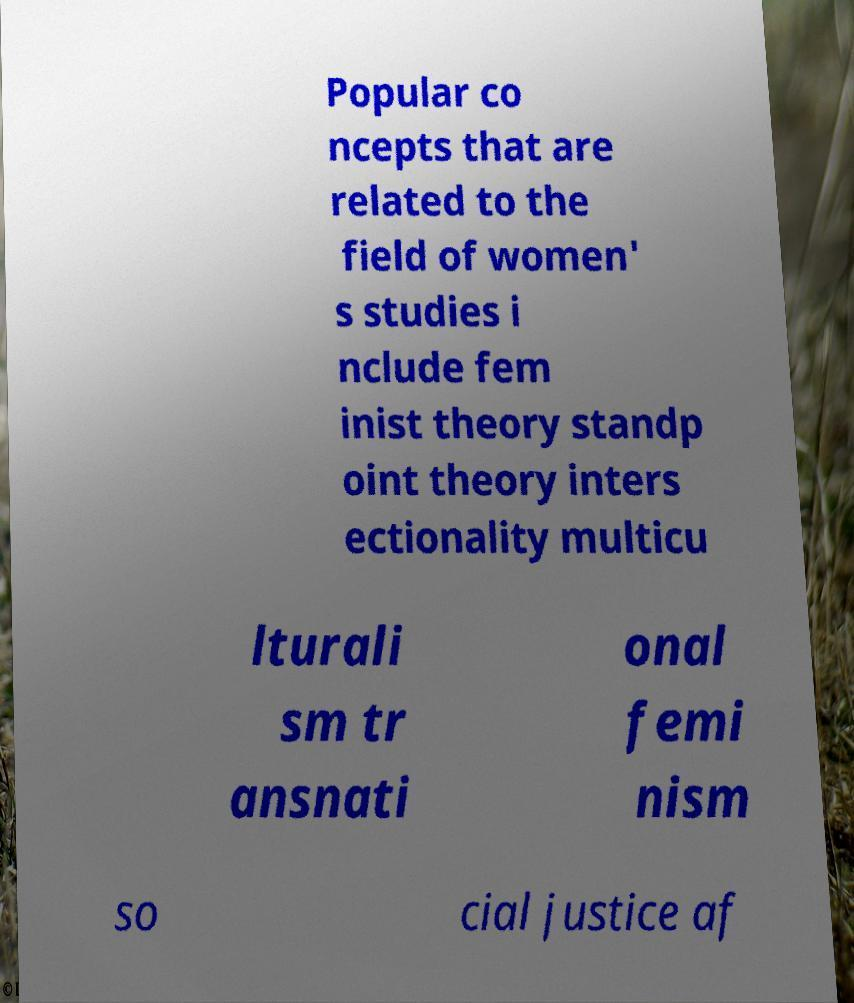For documentation purposes, I need the text within this image transcribed. Could you provide that? Popular co ncepts that are related to the field of women' s studies i nclude fem inist theory standp oint theory inters ectionality multicu lturali sm tr ansnati onal femi nism so cial justice af 